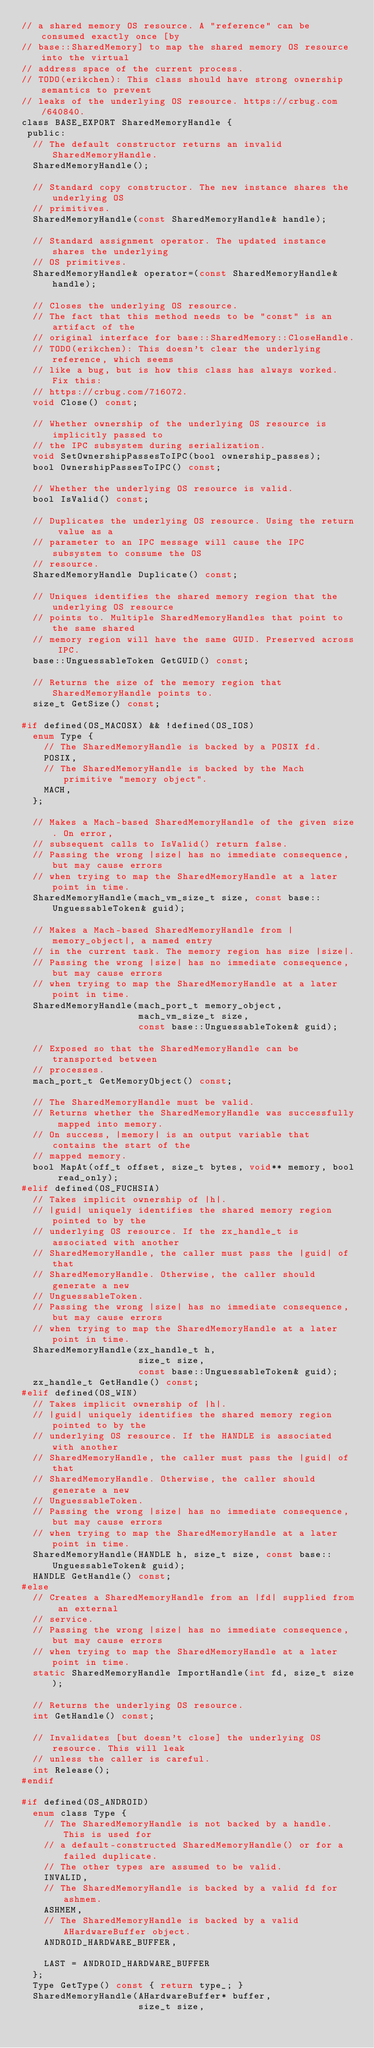<code> <loc_0><loc_0><loc_500><loc_500><_C_>// a shared memory OS resource. A "reference" can be consumed exactly once [by
// base::SharedMemory] to map the shared memory OS resource into the virtual
// address space of the current process.
// TODO(erikchen): This class should have strong ownership semantics to prevent
// leaks of the underlying OS resource. https://crbug.com/640840.
class BASE_EXPORT SharedMemoryHandle {
 public:
  // The default constructor returns an invalid SharedMemoryHandle.
  SharedMemoryHandle();

  // Standard copy constructor. The new instance shares the underlying OS
  // primitives.
  SharedMemoryHandle(const SharedMemoryHandle& handle);

  // Standard assignment operator. The updated instance shares the underlying
  // OS primitives.
  SharedMemoryHandle& operator=(const SharedMemoryHandle& handle);

  // Closes the underlying OS resource.
  // The fact that this method needs to be "const" is an artifact of the
  // original interface for base::SharedMemory::CloseHandle.
  // TODO(erikchen): This doesn't clear the underlying reference, which seems
  // like a bug, but is how this class has always worked. Fix this:
  // https://crbug.com/716072.
  void Close() const;

  // Whether ownership of the underlying OS resource is implicitly passed to
  // the IPC subsystem during serialization.
  void SetOwnershipPassesToIPC(bool ownership_passes);
  bool OwnershipPassesToIPC() const;

  // Whether the underlying OS resource is valid.
  bool IsValid() const;

  // Duplicates the underlying OS resource. Using the return value as a
  // parameter to an IPC message will cause the IPC subsystem to consume the OS
  // resource.
  SharedMemoryHandle Duplicate() const;

  // Uniques identifies the shared memory region that the underlying OS resource
  // points to. Multiple SharedMemoryHandles that point to the same shared
  // memory region will have the same GUID. Preserved across IPC.
  base::UnguessableToken GetGUID() const;

  // Returns the size of the memory region that SharedMemoryHandle points to.
  size_t GetSize() const;

#if defined(OS_MACOSX) && !defined(OS_IOS)
  enum Type {
    // The SharedMemoryHandle is backed by a POSIX fd.
    POSIX,
    // The SharedMemoryHandle is backed by the Mach primitive "memory object".
    MACH,
  };

  // Makes a Mach-based SharedMemoryHandle of the given size. On error,
  // subsequent calls to IsValid() return false.
  // Passing the wrong |size| has no immediate consequence, but may cause errors
  // when trying to map the SharedMemoryHandle at a later point in time.
  SharedMemoryHandle(mach_vm_size_t size, const base::UnguessableToken& guid);

  // Makes a Mach-based SharedMemoryHandle from |memory_object|, a named entry
  // in the current task. The memory region has size |size|.
  // Passing the wrong |size| has no immediate consequence, but may cause errors
  // when trying to map the SharedMemoryHandle at a later point in time.
  SharedMemoryHandle(mach_port_t memory_object,
                     mach_vm_size_t size,
                     const base::UnguessableToken& guid);

  // Exposed so that the SharedMemoryHandle can be transported between
  // processes.
  mach_port_t GetMemoryObject() const;

  // The SharedMemoryHandle must be valid.
  // Returns whether the SharedMemoryHandle was successfully mapped into memory.
  // On success, |memory| is an output variable that contains the start of the
  // mapped memory.
  bool MapAt(off_t offset, size_t bytes, void** memory, bool read_only);
#elif defined(OS_FUCHSIA)
  // Takes implicit ownership of |h|.
  // |guid| uniquely identifies the shared memory region pointed to by the
  // underlying OS resource. If the zx_handle_t is associated with another
  // SharedMemoryHandle, the caller must pass the |guid| of that
  // SharedMemoryHandle. Otherwise, the caller should generate a new
  // UnguessableToken.
  // Passing the wrong |size| has no immediate consequence, but may cause errors
  // when trying to map the SharedMemoryHandle at a later point in time.
  SharedMemoryHandle(zx_handle_t h,
                     size_t size,
                     const base::UnguessableToken& guid);
  zx_handle_t GetHandle() const;
#elif defined(OS_WIN)
  // Takes implicit ownership of |h|.
  // |guid| uniquely identifies the shared memory region pointed to by the
  // underlying OS resource. If the HANDLE is associated with another
  // SharedMemoryHandle, the caller must pass the |guid| of that
  // SharedMemoryHandle. Otherwise, the caller should generate a new
  // UnguessableToken.
  // Passing the wrong |size| has no immediate consequence, but may cause errors
  // when trying to map the SharedMemoryHandle at a later point in time.
  SharedMemoryHandle(HANDLE h, size_t size, const base::UnguessableToken& guid);
  HANDLE GetHandle() const;
#else
  // Creates a SharedMemoryHandle from an |fd| supplied from an external
  // service.
  // Passing the wrong |size| has no immediate consequence, but may cause errors
  // when trying to map the SharedMemoryHandle at a later point in time.
  static SharedMemoryHandle ImportHandle(int fd, size_t size);

  // Returns the underlying OS resource.
  int GetHandle() const;

  // Invalidates [but doesn't close] the underlying OS resource. This will leak
  // unless the caller is careful.
  int Release();
#endif

#if defined(OS_ANDROID)
  enum class Type {
    // The SharedMemoryHandle is not backed by a handle. This is used for
    // a default-constructed SharedMemoryHandle() or for a failed duplicate.
    // The other types are assumed to be valid.
    INVALID,
    // The SharedMemoryHandle is backed by a valid fd for ashmem.
    ASHMEM,
    // The SharedMemoryHandle is backed by a valid AHardwareBuffer object.
    ANDROID_HARDWARE_BUFFER,

    LAST = ANDROID_HARDWARE_BUFFER
  };
  Type GetType() const { return type_; }
  SharedMemoryHandle(AHardwareBuffer* buffer,
                     size_t size,</code> 